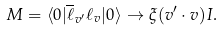<formula> <loc_0><loc_0><loc_500><loc_500>M = \langle 0 | \overline { \ell } _ { v ^ { \prime } } \ell _ { v } | 0 \rangle \rightarrow \xi ( v ^ { \prime } \cdot v ) I .</formula> 